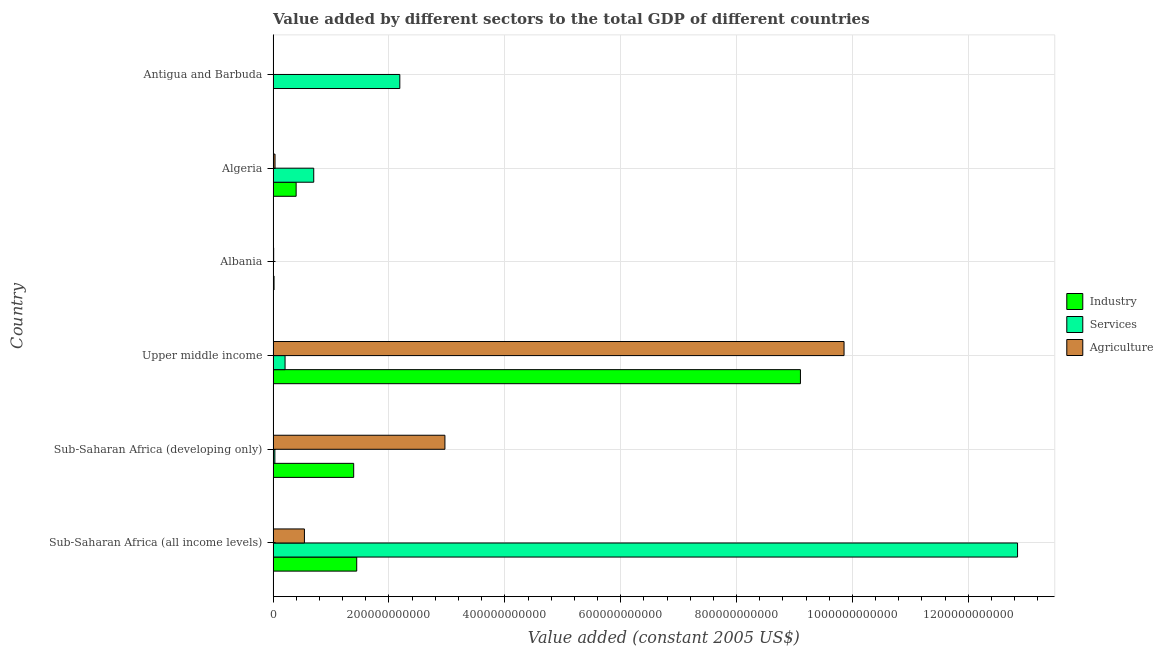How many different coloured bars are there?
Give a very brief answer. 3. How many groups of bars are there?
Keep it short and to the point. 6. Are the number of bars per tick equal to the number of legend labels?
Provide a short and direct response. Yes. Are the number of bars on each tick of the Y-axis equal?
Your response must be concise. Yes. How many bars are there on the 3rd tick from the bottom?
Your answer should be very brief. 3. What is the label of the 3rd group of bars from the top?
Provide a short and direct response. Albania. What is the value added by industrial sector in Algeria?
Keep it short and to the point. 3.97e+1. Across all countries, what is the maximum value added by services?
Keep it short and to the point. 1.29e+12. Across all countries, what is the minimum value added by industrial sector?
Your answer should be very brief. 5.55e+07. In which country was the value added by services maximum?
Give a very brief answer. Sub-Saharan Africa (all income levels). In which country was the value added by industrial sector minimum?
Make the answer very short. Antigua and Barbuda. What is the total value added by agricultural sector in the graph?
Keep it short and to the point. 1.34e+12. What is the difference between the value added by agricultural sector in Sub-Saharan Africa (all income levels) and that in Sub-Saharan Africa (developing only)?
Offer a terse response. -2.43e+11. What is the difference between the value added by services in Albania and the value added by industrial sector in Upper middle income?
Keep it short and to the point. -9.10e+11. What is the average value added by services per country?
Keep it short and to the point. 2.66e+11. What is the difference between the value added by industrial sector and value added by agricultural sector in Algeria?
Give a very brief answer. 3.64e+1. What is the ratio of the value added by services in Albania to that in Upper middle income?
Provide a short and direct response. 0.02. Is the difference between the value added by services in Albania and Sub-Saharan Africa (all income levels) greater than the difference between the value added by agricultural sector in Albania and Sub-Saharan Africa (all income levels)?
Your answer should be very brief. No. What is the difference between the highest and the second highest value added by agricultural sector?
Your answer should be very brief. 6.89e+11. What is the difference between the highest and the lowest value added by industrial sector?
Your answer should be compact. 9.10e+11. Is the sum of the value added by industrial sector in Albania and Algeria greater than the maximum value added by services across all countries?
Provide a succinct answer. No. What does the 1st bar from the top in Sub-Saharan Africa (all income levels) represents?
Your answer should be very brief. Agriculture. What does the 2nd bar from the bottom in Sub-Saharan Africa (all income levels) represents?
Your answer should be compact. Services. Is it the case that in every country, the sum of the value added by industrial sector and value added by services is greater than the value added by agricultural sector?
Your response must be concise. No. How many bars are there?
Provide a short and direct response. 18. How many countries are there in the graph?
Provide a succinct answer. 6. What is the difference between two consecutive major ticks on the X-axis?
Your answer should be compact. 2.00e+11. Are the values on the major ticks of X-axis written in scientific E-notation?
Offer a terse response. No. Does the graph contain any zero values?
Your response must be concise. No. Where does the legend appear in the graph?
Your answer should be very brief. Center right. How are the legend labels stacked?
Offer a very short reply. Vertical. What is the title of the graph?
Provide a succinct answer. Value added by different sectors to the total GDP of different countries. What is the label or title of the X-axis?
Offer a very short reply. Value added (constant 2005 US$). What is the label or title of the Y-axis?
Make the answer very short. Country. What is the Value added (constant 2005 US$) of Industry in Sub-Saharan Africa (all income levels)?
Ensure brevity in your answer.  1.44e+11. What is the Value added (constant 2005 US$) of Services in Sub-Saharan Africa (all income levels)?
Your response must be concise. 1.29e+12. What is the Value added (constant 2005 US$) in Agriculture in Sub-Saharan Africa (all income levels)?
Your answer should be compact. 5.40e+1. What is the Value added (constant 2005 US$) in Industry in Sub-Saharan Africa (developing only)?
Your response must be concise. 1.39e+11. What is the Value added (constant 2005 US$) in Services in Sub-Saharan Africa (developing only)?
Offer a very short reply. 3.00e+09. What is the Value added (constant 2005 US$) of Agriculture in Sub-Saharan Africa (developing only)?
Your answer should be compact. 2.97e+11. What is the Value added (constant 2005 US$) in Industry in Upper middle income?
Keep it short and to the point. 9.10e+11. What is the Value added (constant 2005 US$) in Services in Upper middle income?
Provide a short and direct response. 2.06e+1. What is the Value added (constant 2005 US$) of Agriculture in Upper middle income?
Give a very brief answer. 9.86e+11. What is the Value added (constant 2005 US$) in Industry in Albania?
Provide a short and direct response. 1.58e+09. What is the Value added (constant 2005 US$) in Services in Albania?
Offer a very short reply. 3.44e+08. What is the Value added (constant 2005 US$) in Agriculture in Albania?
Provide a short and direct response. 9.20e+08. What is the Value added (constant 2005 US$) of Industry in Algeria?
Your response must be concise. 3.97e+1. What is the Value added (constant 2005 US$) in Services in Algeria?
Offer a terse response. 7.01e+1. What is the Value added (constant 2005 US$) of Agriculture in Algeria?
Offer a very short reply. 3.29e+09. What is the Value added (constant 2005 US$) in Industry in Antigua and Barbuda?
Your answer should be compact. 5.55e+07. What is the Value added (constant 2005 US$) in Services in Antigua and Barbuda?
Give a very brief answer. 2.19e+11. What is the Value added (constant 2005 US$) of Agriculture in Antigua and Barbuda?
Your response must be concise. 1.08e+07. Across all countries, what is the maximum Value added (constant 2005 US$) of Industry?
Give a very brief answer. 9.10e+11. Across all countries, what is the maximum Value added (constant 2005 US$) of Services?
Your response must be concise. 1.29e+12. Across all countries, what is the maximum Value added (constant 2005 US$) in Agriculture?
Ensure brevity in your answer.  9.86e+11. Across all countries, what is the minimum Value added (constant 2005 US$) in Industry?
Provide a succinct answer. 5.55e+07. Across all countries, what is the minimum Value added (constant 2005 US$) in Services?
Keep it short and to the point. 3.44e+08. Across all countries, what is the minimum Value added (constant 2005 US$) in Agriculture?
Provide a short and direct response. 1.08e+07. What is the total Value added (constant 2005 US$) in Industry in the graph?
Ensure brevity in your answer.  1.23e+12. What is the total Value added (constant 2005 US$) of Services in the graph?
Offer a very short reply. 1.60e+12. What is the total Value added (constant 2005 US$) of Agriculture in the graph?
Give a very brief answer. 1.34e+12. What is the difference between the Value added (constant 2005 US$) in Industry in Sub-Saharan Africa (all income levels) and that in Sub-Saharan Africa (developing only)?
Provide a succinct answer. 5.25e+09. What is the difference between the Value added (constant 2005 US$) of Services in Sub-Saharan Africa (all income levels) and that in Sub-Saharan Africa (developing only)?
Your answer should be compact. 1.28e+12. What is the difference between the Value added (constant 2005 US$) in Agriculture in Sub-Saharan Africa (all income levels) and that in Sub-Saharan Africa (developing only)?
Your answer should be compact. -2.43e+11. What is the difference between the Value added (constant 2005 US$) of Industry in Sub-Saharan Africa (all income levels) and that in Upper middle income?
Provide a succinct answer. -7.66e+11. What is the difference between the Value added (constant 2005 US$) of Services in Sub-Saharan Africa (all income levels) and that in Upper middle income?
Your answer should be compact. 1.26e+12. What is the difference between the Value added (constant 2005 US$) of Agriculture in Sub-Saharan Africa (all income levels) and that in Upper middle income?
Keep it short and to the point. -9.31e+11. What is the difference between the Value added (constant 2005 US$) in Industry in Sub-Saharan Africa (all income levels) and that in Albania?
Provide a short and direct response. 1.43e+11. What is the difference between the Value added (constant 2005 US$) in Services in Sub-Saharan Africa (all income levels) and that in Albania?
Your response must be concise. 1.28e+12. What is the difference between the Value added (constant 2005 US$) of Agriculture in Sub-Saharan Africa (all income levels) and that in Albania?
Keep it short and to the point. 5.31e+1. What is the difference between the Value added (constant 2005 US$) of Industry in Sub-Saharan Africa (all income levels) and that in Algeria?
Keep it short and to the point. 1.05e+11. What is the difference between the Value added (constant 2005 US$) of Services in Sub-Saharan Africa (all income levels) and that in Algeria?
Give a very brief answer. 1.21e+12. What is the difference between the Value added (constant 2005 US$) of Agriculture in Sub-Saharan Africa (all income levels) and that in Algeria?
Make the answer very short. 5.07e+1. What is the difference between the Value added (constant 2005 US$) of Industry in Sub-Saharan Africa (all income levels) and that in Antigua and Barbuda?
Your response must be concise. 1.44e+11. What is the difference between the Value added (constant 2005 US$) in Services in Sub-Saharan Africa (all income levels) and that in Antigua and Barbuda?
Give a very brief answer. 1.07e+12. What is the difference between the Value added (constant 2005 US$) in Agriculture in Sub-Saharan Africa (all income levels) and that in Antigua and Barbuda?
Your answer should be compact. 5.40e+1. What is the difference between the Value added (constant 2005 US$) of Industry in Sub-Saharan Africa (developing only) and that in Upper middle income?
Make the answer very short. -7.71e+11. What is the difference between the Value added (constant 2005 US$) in Services in Sub-Saharan Africa (developing only) and that in Upper middle income?
Give a very brief answer. -1.76e+1. What is the difference between the Value added (constant 2005 US$) of Agriculture in Sub-Saharan Africa (developing only) and that in Upper middle income?
Your answer should be very brief. -6.89e+11. What is the difference between the Value added (constant 2005 US$) of Industry in Sub-Saharan Africa (developing only) and that in Albania?
Provide a short and direct response. 1.37e+11. What is the difference between the Value added (constant 2005 US$) of Services in Sub-Saharan Africa (developing only) and that in Albania?
Give a very brief answer. 2.66e+09. What is the difference between the Value added (constant 2005 US$) in Agriculture in Sub-Saharan Africa (developing only) and that in Albania?
Provide a short and direct response. 2.96e+11. What is the difference between the Value added (constant 2005 US$) in Industry in Sub-Saharan Africa (developing only) and that in Algeria?
Offer a terse response. 9.93e+1. What is the difference between the Value added (constant 2005 US$) in Services in Sub-Saharan Africa (developing only) and that in Algeria?
Offer a very short reply. -6.71e+1. What is the difference between the Value added (constant 2005 US$) of Agriculture in Sub-Saharan Africa (developing only) and that in Algeria?
Your response must be concise. 2.93e+11. What is the difference between the Value added (constant 2005 US$) in Industry in Sub-Saharan Africa (developing only) and that in Antigua and Barbuda?
Provide a short and direct response. 1.39e+11. What is the difference between the Value added (constant 2005 US$) in Services in Sub-Saharan Africa (developing only) and that in Antigua and Barbuda?
Make the answer very short. -2.16e+11. What is the difference between the Value added (constant 2005 US$) of Agriculture in Sub-Saharan Africa (developing only) and that in Antigua and Barbuda?
Offer a very short reply. 2.97e+11. What is the difference between the Value added (constant 2005 US$) of Industry in Upper middle income and that in Albania?
Keep it short and to the point. 9.09e+11. What is the difference between the Value added (constant 2005 US$) of Services in Upper middle income and that in Albania?
Provide a short and direct response. 2.03e+1. What is the difference between the Value added (constant 2005 US$) of Agriculture in Upper middle income and that in Albania?
Give a very brief answer. 9.85e+11. What is the difference between the Value added (constant 2005 US$) in Industry in Upper middle income and that in Algeria?
Your response must be concise. 8.71e+11. What is the difference between the Value added (constant 2005 US$) in Services in Upper middle income and that in Algeria?
Provide a succinct answer. -4.95e+1. What is the difference between the Value added (constant 2005 US$) of Agriculture in Upper middle income and that in Algeria?
Offer a terse response. 9.82e+11. What is the difference between the Value added (constant 2005 US$) in Industry in Upper middle income and that in Antigua and Barbuda?
Offer a terse response. 9.10e+11. What is the difference between the Value added (constant 2005 US$) in Services in Upper middle income and that in Antigua and Barbuda?
Ensure brevity in your answer.  -1.98e+11. What is the difference between the Value added (constant 2005 US$) in Agriculture in Upper middle income and that in Antigua and Barbuda?
Offer a very short reply. 9.86e+11. What is the difference between the Value added (constant 2005 US$) in Industry in Albania and that in Algeria?
Offer a terse response. -3.82e+1. What is the difference between the Value added (constant 2005 US$) of Services in Albania and that in Algeria?
Your answer should be very brief. -6.98e+1. What is the difference between the Value added (constant 2005 US$) of Agriculture in Albania and that in Algeria?
Your response must be concise. -2.37e+09. What is the difference between the Value added (constant 2005 US$) of Industry in Albania and that in Antigua and Barbuda?
Keep it short and to the point. 1.52e+09. What is the difference between the Value added (constant 2005 US$) in Services in Albania and that in Antigua and Barbuda?
Keep it short and to the point. -2.18e+11. What is the difference between the Value added (constant 2005 US$) of Agriculture in Albania and that in Antigua and Barbuda?
Make the answer very short. 9.09e+08. What is the difference between the Value added (constant 2005 US$) in Industry in Algeria and that in Antigua and Barbuda?
Your answer should be compact. 3.97e+1. What is the difference between the Value added (constant 2005 US$) of Services in Algeria and that in Antigua and Barbuda?
Provide a succinct answer. -1.49e+11. What is the difference between the Value added (constant 2005 US$) in Agriculture in Algeria and that in Antigua and Barbuda?
Ensure brevity in your answer.  3.28e+09. What is the difference between the Value added (constant 2005 US$) of Industry in Sub-Saharan Africa (all income levels) and the Value added (constant 2005 US$) of Services in Sub-Saharan Africa (developing only)?
Ensure brevity in your answer.  1.41e+11. What is the difference between the Value added (constant 2005 US$) in Industry in Sub-Saharan Africa (all income levels) and the Value added (constant 2005 US$) in Agriculture in Sub-Saharan Africa (developing only)?
Offer a terse response. -1.52e+11. What is the difference between the Value added (constant 2005 US$) of Services in Sub-Saharan Africa (all income levels) and the Value added (constant 2005 US$) of Agriculture in Sub-Saharan Africa (developing only)?
Provide a succinct answer. 9.88e+11. What is the difference between the Value added (constant 2005 US$) of Industry in Sub-Saharan Africa (all income levels) and the Value added (constant 2005 US$) of Services in Upper middle income?
Give a very brief answer. 1.24e+11. What is the difference between the Value added (constant 2005 US$) of Industry in Sub-Saharan Africa (all income levels) and the Value added (constant 2005 US$) of Agriculture in Upper middle income?
Offer a very short reply. -8.41e+11. What is the difference between the Value added (constant 2005 US$) of Services in Sub-Saharan Africa (all income levels) and the Value added (constant 2005 US$) of Agriculture in Upper middle income?
Keep it short and to the point. 3.00e+11. What is the difference between the Value added (constant 2005 US$) in Industry in Sub-Saharan Africa (all income levels) and the Value added (constant 2005 US$) in Services in Albania?
Provide a short and direct response. 1.44e+11. What is the difference between the Value added (constant 2005 US$) of Industry in Sub-Saharan Africa (all income levels) and the Value added (constant 2005 US$) of Agriculture in Albania?
Ensure brevity in your answer.  1.43e+11. What is the difference between the Value added (constant 2005 US$) in Services in Sub-Saharan Africa (all income levels) and the Value added (constant 2005 US$) in Agriculture in Albania?
Provide a succinct answer. 1.28e+12. What is the difference between the Value added (constant 2005 US$) of Industry in Sub-Saharan Africa (all income levels) and the Value added (constant 2005 US$) of Services in Algeria?
Your answer should be very brief. 7.42e+1. What is the difference between the Value added (constant 2005 US$) in Industry in Sub-Saharan Africa (all income levels) and the Value added (constant 2005 US$) in Agriculture in Algeria?
Your response must be concise. 1.41e+11. What is the difference between the Value added (constant 2005 US$) in Services in Sub-Saharan Africa (all income levels) and the Value added (constant 2005 US$) in Agriculture in Algeria?
Make the answer very short. 1.28e+12. What is the difference between the Value added (constant 2005 US$) of Industry in Sub-Saharan Africa (all income levels) and the Value added (constant 2005 US$) of Services in Antigua and Barbuda?
Provide a succinct answer. -7.44e+1. What is the difference between the Value added (constant 2005 US$) of Industry in Sub-Saharan Africa (all income levels) and the Value added (constant 2005 US$) of Agriculture in Antigua and Barbuda?
Offer a very short reply. 1.44e+11. What is the difference between the Value added (constant 2005 US$) of Services in Sub-Saharan Africa (all income levels) and the Value added (constant 2005 US$) of Agriculture in Antigua and Barbuda?
Your answer should be very brief. 1.29e+12. What is the difference between the Value added (constant 2005 US$) in Industry in Sub-Saharan Africa (developing only) and the Value added (constant 2005 US$) in Services in Upper middle income?
Your answer should be very brief. 1.18e+11. What is the difference between the Value added (constant 2005 US$) in Industry in Sub-Saharan Africa (developing only) and the Value added (constant 2005 US$) in Agriculture in Upper middle income?
Give a very brief answer. -8.46e+11. What is the difference between the Value added (constant 2005 US$) in Services in Sub-Saharan Africa (developing only) and the Value added (constant 2005 US$) in Agriculture in Upper middle income?
Provide a succinct answer. -9.83e+11. What is the difference between the Value added (constant 2005 US$) in Industry in Sub-Saharan Africa (developing only) and the Value added (constant 2005 US$) in Services in Albania?
Make the answer very short. 1.39e+11. What is the difference between the Value added (constant 2005 US$) of Industry in Sub-Saharan Africa (developing only) and the Value added (constant 2005 US$) of Agriculture in Albania?
Provide a short and direct response. 1.38e+11. What is the difference between the Value added (constant 2005 US$) in Services in Sub-Saharan Africa (developing only) and the Value added (constant 2005 US$) in Agriculture in Albania?
Give a very brief answer. 2.08e+09. What is the difference between the Value added (constant 2005 US$) of Industry in Sub-Saharan Africa (developing only) and the Value added (constant 2005 US$) of Services in Algeria?
Your answer should be compact. 6.90e+1. What is the difference between the Value added (constant 2005 US$) in Industry in Sub-Saharan Africa (developing only) and the Value added (constant 2005 US$) in Agriculture in Algeria?
Your answer should be compact. 1.36e+11. What is the difference between the Value added (constant 2005 US$) in Services in Sub-Saharan Africa (developing only) and the Value added (constant 2005 US$) in Agriculture in Algeria?
Offer a terse response. -2.90e+08. What is the difference between the Value added (constant 2005 US$) in Industry in Sub-Saharan Africa (developing only) and the Value added (constant 2005 US$) in Services in Antigua and Barbuda?
Give a very brief answer. -7.96e+1. What is the difference between the Value added (constant 2005 US$) of Industry in Sub-Saharan Africa (developing only) and the Value added (constant 2005 US$) of Agriculture in Antigua and Barbuda?
Keep it short and to the point. 1.39e+11. What is the difference between the Value added (constant 2005 US$) of Services in Sub-Saharan Africa (developing only) and the Value added (constant 2005 US$) of Agriculture in Antigua and Barbuda?
Provide a succinct answer. 2.99e+09. What is the difference between the Value added (constant 2005 US$) in Industry in Upper middle income and the Value added (constant 2005 US$) in Services in Albania?
Keep it short and to the point. 9.10e+11. What is the difference between the Value added (constant 2005 US$) of Industry in Upper middle income and the Value added (constant 2005 US$) of Agriculture in Albania?
Make the answer very short. 9.09e+11. What is the difference between the Value added (constant 2005 US$) of Services in Upper middle income and the Value added (constant 2005 US$) of Agriculture in Albania?
Your answer should be compact. 1.97e+1. What is the difference between the Value added (constant 2005 US$) in Industry in Upper middle income and the Value added (constant 2005 US$) in Services in Algeria?
Your response must be concise. 8.40e+11. What is the difference between the Value added (constant 2005 US$) in Industry in Upper middle income and the Value added (constant 2005 US$) in Agriculture in Algeria?
Make the answer very short. 9.07e+11. What is the difference between the Value added (constant 2005 US$) in Services in Upper middle income and the Value added (constant 2005 US$) in Agriculture in Algeria?
Give a very brief answer. 1.73e+1. What is the difference between the Value added (constant 2005 US$) of Industry in Upper middle income and the Value added (constant 2005 US$) of Services in Antigua and Barbuda?
Keep it short and to the point. 6.92e+11. What is the difference between the Value added (constant 2005 US$) in Industry in Upper middle income and the Value added (constant 2005 US$) in Agriculture in Antigua and Barbuda?
Make the answer very short. 9.10e+11. What is the difference between the Value added (constant 2005 US$) of Services in Upper middle income and the Value added (constant 2005 US$) of Agriculture in Antigua and Barbuda?
Provide a succinct answer. 2.06e+1. What is the difference between the Value added (constant 2005 US$) in Industry in Albania and the Value added (constant 2005 US$) in Services in Algeria?
Provide a succinct answer. -6.85e+1. What is the difference between the Value added (constant 2005 US$) of Industry in Albania and the Value added (constant 2005 US$) of Agriculture in Algeria?
Make the answer very short. -1.71e+09. What is the difference between the Value added (constant 2005 US$) in Services in Albania and the Value added (constant 2005 US$) in Agriculture in Algeria?
Keep it short and to the point. -2.95e+09. What is the difference between the Value added (constant 2005 US$) in Industry in Albania and the Value added (constant 2005 US$) in Services in Antigua and Barbuda?
Provide a short and direct response. -2.17e+11. What is the difference between the Value added (constant 2005 US$) of Industry in Albania and the Value added (constant 2005 US$) of Agriculture in Antigua and Barbuda?
Keep it short and to the point. 1.57e+09. What is the difference between the Value added (constant 2005 US$) of Services in Albania and the Value added (constant 2005 US$) of Agriculture in Antigua and Barbuda?
Your answer should be compact. 3.34e+08. What is the difference between the Value added (constant 2005 US$) in Industry in Algeria and the Value added (constant 2005 US$) in Services in Antigua and Barbuda?
Provide a succinct answer. -1.79e+11. What is the difference between the Value added (constant 2005 US$) of Industry in Algeria and the Value added (constant 2005 US$) of Agriculture in Antigua and Barbuda?
Provide a succinct answer. 3.97e+1. What is the difference between the Value added (constant 2005 US$) of Services in Algeria and the Value added (constant 2005 US$) of Agriculture in Antigua and Barbuda?
Offer a very short reply. 7.01e+1. What is the average Value added (constant 2005 US$) of Industry per country?
Make the answer very short. 2.06e+11. What is the average Value added (constant 2005 US$) of Services per country?
Give a very brief answer. 2.66e+11. What is the average Value added (constant 2005 US$) in Agriculture per country?
Your response must be concise. 2.23e+11. What is the difference between the Value added (constant 2005 US$) in Industry and Value added (constant 2005 US$) in Services in Sub-Saharan Africa (all income levels)?
Your answer should be compact. -1.14e+12. What is the difference between the Value added (constant 2005 US$) of Industry and Value added (constant 2005 US$) of Agriculture in Sub-Saharan Africa (all income levels)?
Provide a short and direct response. 9.03e+1. What is the difference between the Value added (constant 2005 US$) in Services and Value added (constant 2005 US$) in Agriculture in Sub-Saharan Africa (all income levels)?
Offer a terse response. 1.23e+12. What is the difference between the Value added (constant 2005 US$) in Industry and Value added (constant 2005 US$) in Services in Sub-Saharan Africa (developing only)?
Your response must be concise. 1.36e+11. What is the difference between the Value added (constant 2005 US$) of Industry and Value added (constant 2005 US$) of Agriculture in Sub-Saharan Africa (developing only)?
Offer a very short reply. -1.57e+11. What is the difference between the Value added (constant 2005 US$) of Services and Value added (constant 2005 US$) of Agriculture in Sub-Saharan Africa (developing only)?
Provide a short and direct response. -2.94e+11. What is the difference between the Value added (constant 2005 US$) in Industry and Value added (constant 2005 US$) in Services in Upper middle income?
Provide a short and direct response. 8.90e+11. What is the difference between the Value added (constant 2005 US$) of Industry and Value added (constant 2005 US$) of Agriculture in Upper middle income?
Offer a terse response. -7.53e+1. What is the difference between the Value added (constant 2005 US$) of Services and Value added (constant 2005 US$) of Agriculture in Upper middle income?
Keep it short and to the point. -9.65e+11. What is the difference between the Value added (constant 2005 US$) of Industry and Value added (constant 2005 US$) of Services in Albania?
Give a very brief answer. 1.23e+09. What is the difference between the Value added (constant 2005 US$) of Industry and Value added (constant 2005 US$) of Agriculture in Albania?
Ensure brevity in your answer.  6.57e+08. What is the difference between the Value added (constant 2005 US$) of Services and Value added (constant 2005 US$) of Agriculture in Albania?
Keep it short and to the point. -5.76e+08. What is the difference between the Value added (constant 2005 US$) of Industry and Value added (constant 2005 US$) of Services in Algeria?
Provide a succinct answer. -3.04e+1. What is the difference between the Value added (constant 2005 US$) in Industry and Value added (constant 2005 US$) in Agriculture in Algeria?
Give a very brief answer. 3.64e+1. What is the difference between the Value added (constant 2005 US$) in Services and Value added (constant 2005 US$) in Agriculture in Algeria?
Make the answer very short. 6.68e+1. What is the difference between the Value added (constant 2005 US$) in Industry and Value added (constant 2005 US$) in Services in Antigua and Barbuda?
Provide a short and direct response. -2.19e+11. What is the difference between the Value added (constant 2005 US$) in Industry and Value added (constant 2005 US$) in Agriculture in Antigua and Barbuda?
Your response must be concise. 4.47e+07. What is the difference between the Value added (constant 2005 US$) in Services and Value added (constant 2005 US$) in Agriculture in Antigua and Barbuda?
Ensure brevity in your answer.  2.19e+11. What is the ratio of the Value added (constant 2005 US$) in Industry in Sub-Saharan Africa (all income levels) to that in Sub-Saharan Africa (developing only)?
Your response must be concise. 1.04. What is the ratio of the Value added (constant 2005 US$) of Services in Sub-Saharan Africa (all income levels) to that in Sub-Saharan Africa (developing only)?
Your response must be concise. 428.25. What is the ratio of the Value added (constant 2005 US$) in Agriculture in Sub-Saharan Africa (all income levels) to that in Sub-Saharan Africa (developing only)?
Provide a short and direct response. 0.18. What is the ratio of the Value added (constant 2005 US$) in Industry in Sub-Saharan Africa (all income levels) to that in Upper middle income?
Provide a short and direct response. 0.16. What is the ratio of the Value added (constant 2005 US$) in Services in Sub-Saharan Africa (all income levels) to that in Upper middle income?
Ensure brevity in your answer.  62.31. What is the ratio of the Value added (constant 2005 US$) of Agriculture in Sub-Saharan Africa (all income levels) to that in Upper middle income?
Make the answer very short. 0.05. What is the ratio of the Value added (constant 2005 US$) in Industry in Sub-Saharan Africa (all income levels) to that in Albania?
Provide a succinct answer. 91.51. What is the ratio of the Value added (constant 2005 US$) in Services in Sub-Saharan Africa (all income levels) to that in Albania?
Offer a terse response. 3731.95. What is the ratio of the Value added (constant 2005 US$) of Agriculture in Sub-Saharan Africa (all income levels) to that in Albania?
Offer a terse response. 58.72. What is the ratio of the Value added (constant 2005 US$) of Industry in Sub-Saharan Africa (all income levels) to that in Algeria?
Ensure brevity in your answer.  3.63. What is the ratio of the Value added (constant 2005 US$) of Services in Sub-Saharan Africa (all income levels) to that in Algeria?
Keep it short and to the point. 18.33. What is the ratio of the Value added (constant 2005 US$) of Agriculture in Sub-Saharan Africa (all income levels) to that in Algeria?
Your answer should be very brief. 16.42. What is the ratio of the Value added (constant 2005 US$) of Industry in Sub-Saharan Africa (all income levels) to that in Antigua and Barbuda?
Give a very brief answer. 2600.27. What is the ratio of the Value added (constant 2005 US$) in Services in Sub-Saharan Africa (all income levels) to that in Antigua and Barbuda?
Give a very brief answer. 5.88. What is the ratio of the Value added (constant 2005 US$) of Agriculture in Sub-Saharan Africa (all income levels) to that in Antigua and Barbuda?
Your answer should be very brief. 5007.14. What is the ratio of the Value added (constant 2005 US$) of Industry in Sub-Saharan Africa (developing only) to that in Upper middle income?
Provide a short and direct response. 0.15. What is the ratio of the Value added (constant 2005 US$) in Services in Sub-Saharan Africa (developing only) to that in Upper middle income?
Keep it short and to the point. 0.15. What is the ratio of the Value added (constant 2005 US$) of Agriculture in Sub-Saharan Africa (developing only) to that in Upper middle income?
Give a very brief answer. 0.3. What is the ratio of the Value added (constant 2005 US$) in Industry in Sub-Saharan Africa (developing only) to that in Albania?
Your answer should be very brief. 88.18. What is the ratio of the Value added (constant 2005 US$) in Services in Sub-Saharan Africa (developing only) to that in Albania?
Give a very brief answer. 8.71. What is the ratio of the Value added (constant 2005 US$) in Agriculture in Sub-Saharan Africa (developing only) to that in Albania?
Make the answer very short. 322.32. What is the ratio of the Value added (constant 2005 US$) in Industry in Sub-Saharan Africa (developing only) to that in Algeria?
Offer a very short reply. 3.5. What is the ratio of the Value added (constant 2005 US$) in Services in Sub-Saharan Africa (developing only) to that in Algeria?
Ensure brevity in your answer.  0.04. What is the ratio of the Value added (constant 2005 US$) of Agriculture in Sub-Saharan Africa (developing only) to that in Algeria?
Your answer should be compact. 90.13. What is the ratio of the Value added (constant 2005 US$) of Industry in Sub-Saharan Africa (developing only) to that in Antigua and Barbuda?
Your response must be concise. 2505.59. What is the ratio of the Value added (constant 2005 US$) in Services in Sub-Saharan Africa (developing only) to that in Antigua and Barbuda?
Offer a terse response. 0.01. What is the ratio of the Value added (constant 2005 US$) of Agriculture in Sub-Saharan Africa (developing only) to that in Antigua and Barbuda?
Keep it short and to the point. 2.75e+04. What is the ratio of the Value added (constant 2005 US$) in Industry in Upper middle income to that in Albania?
Your response must be concise. 577.19. What is the ratio of the Value added (constant 2005 US$) in Services in Upper middle income to that in Albania?
Your answer should be compact. 59.9. What is the ratio of the Value added (constant 2005 US$) of Agriculture in Upper middle income to that in Albania?
Your answer should be very brief. 1071.15. What is the ratio of the Value added (constant 2005 US$) in Industry in Upper middle income to that in Algeria?
Offer a terse response. 22.91. What is the ratio of the Value added (constant 2005 US$) in Services in Upper middle income to that in Algeria?
Keep it short and to the point. 0.29. What is the ratio of the Value added (constant 2005 US$) in Agriculture in Upper middle income to that in Algeria?
Make the answer very short. 299.53. What is the ratio of the Value added (constant 2005 US$) of Industry in Upper middle income to that in Antigua and Barbuda?
Provide a short and direct response. 1.64e+04. What is the ratio of the Value added (constant 2005 US$) of Services in Upper middle income to that in Antigua and Barbuda?
Offer a very short reply. 0.09. What is the ratio of the Value added (constant 2005 US$) in Agriculture in Upper middle income to that in Antigua and Barbuda?
Your answer should be very brief. 9.13e+04. What is the ratio of the Value added (constant 2005 US$) in Industry in Albania to that in Algeria?
Provide a short and direct response. 0.04. What is the ratio of the Value added (constant 2005 US$) of Services in Albania to that in Algeria?
Offer a very short reply. 0. What is the ratio of the Value added (constant 2005 US$) in Agriculture in Albania to that in Algeria?
Keep it short and to the point. 0.28. What is the ratio of the Value added (constant 2005 US$) of Industry in Albania to that in Antigua and Barbuda?
Give a very brief answer. 28.41. What is the ratio of the Value added (constant 2005 US$) in Services in Albania to that in Antigua and Barbuda?
Provide a short and direct response. 0. What is the ratio of the Value added (constant 2005 US$) of Agriculture in Albania to that in Antigua and Barbuda?
Offer a very short reply. 85.27. What is the ratio of the Value added (constant 2005 US$) in Industry in Algeria to that in Antigua and Barbuda?
Offer a terse response. 715.86. What is the ratio of the Value added (constant 2005 US$) in Services in Algeria to that in Antigua and Barbuda?
Your response must be concise. 0.32. What is the ratio of the Value added (constant 2005 US$) in Agriculture in Algeria to that in Antigua and Barbuda?
Give a very brief answer. 304.93. What is the difference between the highest and the second highest Value added (constant 2005 US$) in Industry?
Keep it short and to the point. 7.66e+11. What is the difference between the highest and the second highest Value added (constant 2005 US$) of Services?
Provide a short and direct response. 1.07e+12. What is the difference between the highest and the second highest Value added (constant 2005 US$) in Agriculture?
Offer a very short reply. 6.89e+11. What is the difference between the highest and the lowest Value added (constant 2005 US$) of Industry?
Give a very brief answer. 9.10e+11. What is the difference between the highest and the lowest Value added (constant 2005 US$) in Services?
Provide a short and direct response. 1.28e+12. What is the difference between the highest and the lowest Value added (constant 2005 US$) in Agriculture?
Provide a succinct answer. 9.86e+11. 